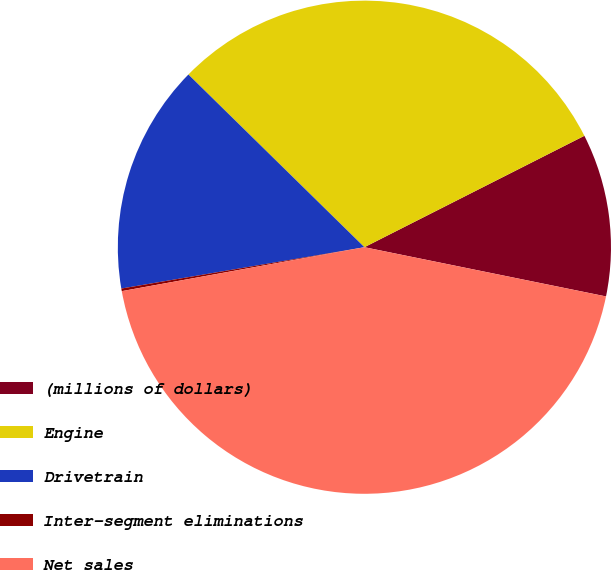Convert chart. <chart><loc_0><loc_0><loc_500><loc_500><pie_chart><fcel>(millions of dollars)<fcel>Engine<fcel>Drivetrain<fcel>Inter-segment eliminations<fcel>Net sales<nl><fcel>10.66%<fcel>30.19%<fcel>15.03%<fcel>0.17%<fcel>43.95%<nl></chart> 